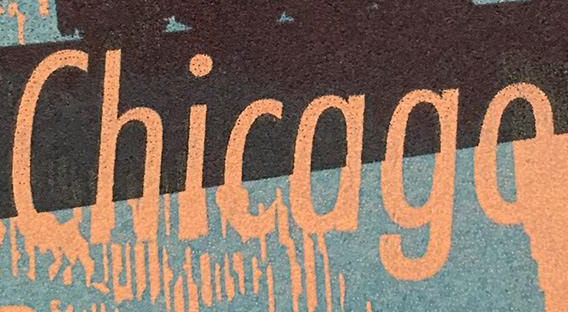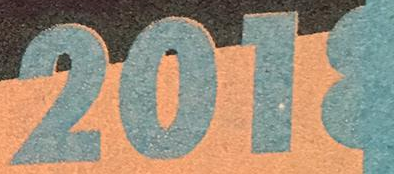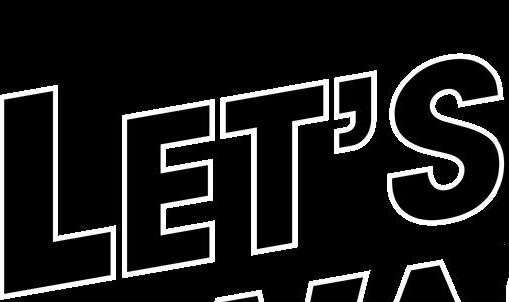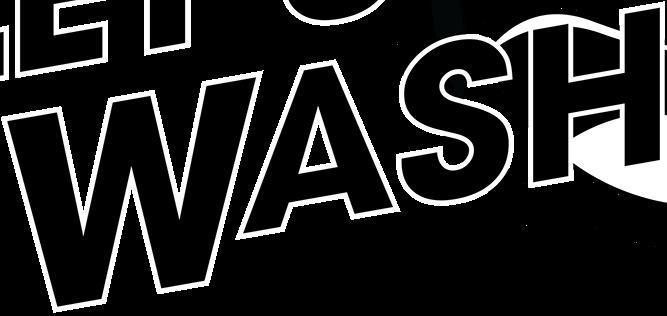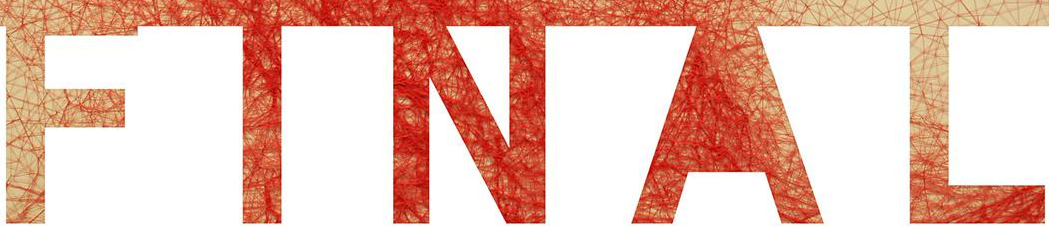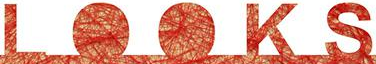What text appears in these images from left to right, separated by a semicolon? Chicago; 2018; LET'S; WASH; FINAL; LOOKS 